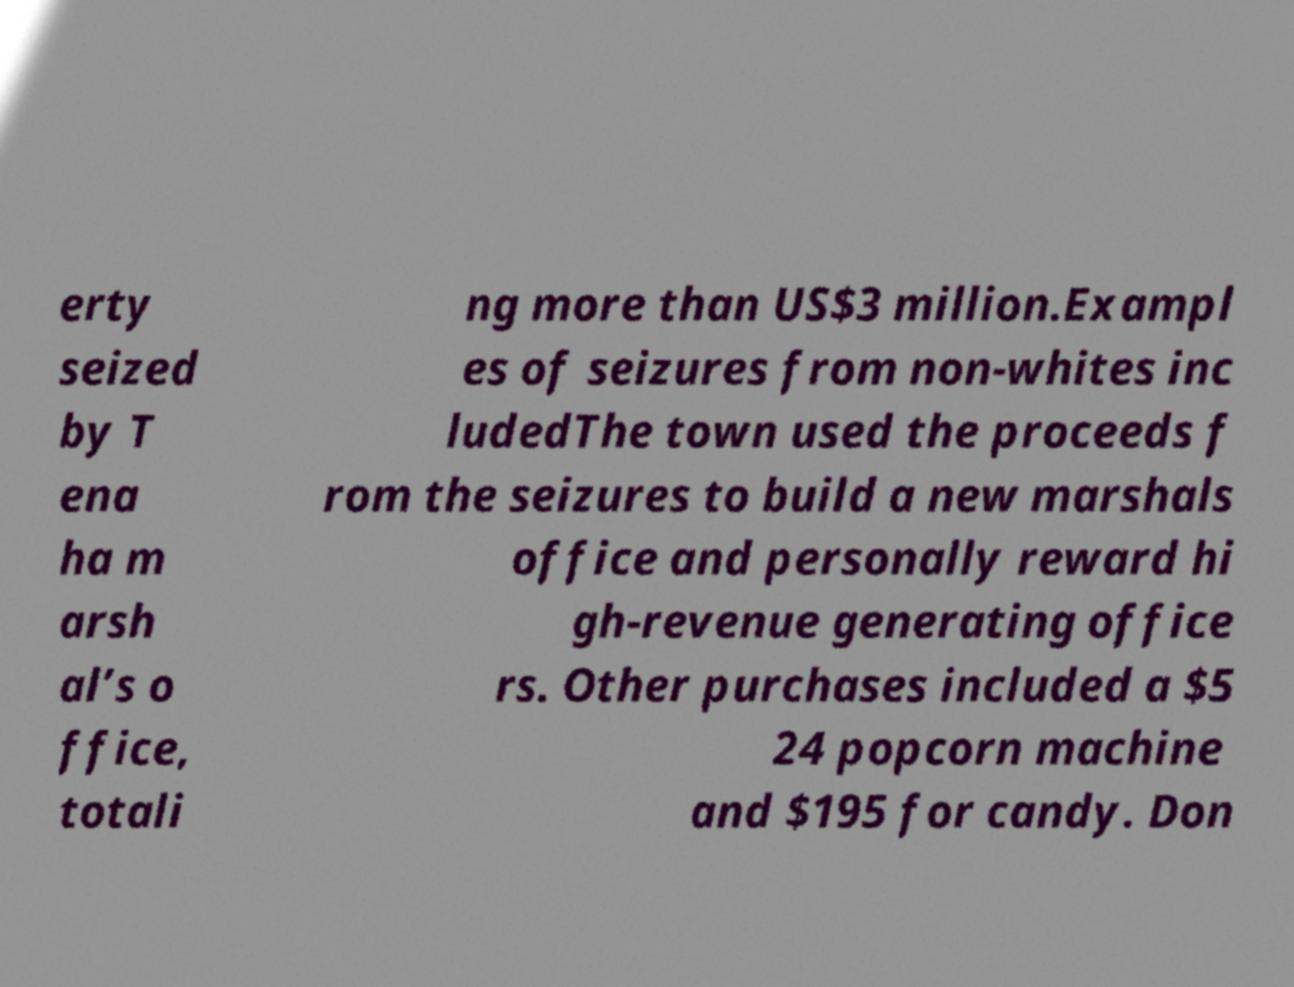Please identify and transcribe the text found in this image. erty seized by T ena ha m arsh al’s o ffice, totali ng more than US$3 million.Exampl es of seizures from non-whites inc ludedThe town used the proceeds f rom the seizures to build a new marshals office and personally reward hi gh-revenue generating office rs. Other purchases included a $5 24 popcorn machine and $195 for candy. Don 